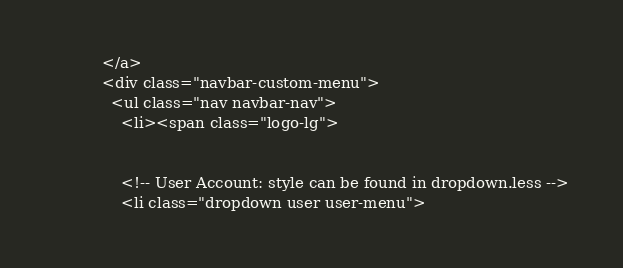Convert code to text. <code><loc_0><loc_0><loc_500><loc_500><_PHP_>          </a>
          <div class="navbar-custom-menu">
            <ul class="nav navbar-nav">
              <li><span class="logo-lg">
              
              
              <!-- User Account: style can be found in dropdown.less -->
              <li class="dropdown user user-menu"></code> 